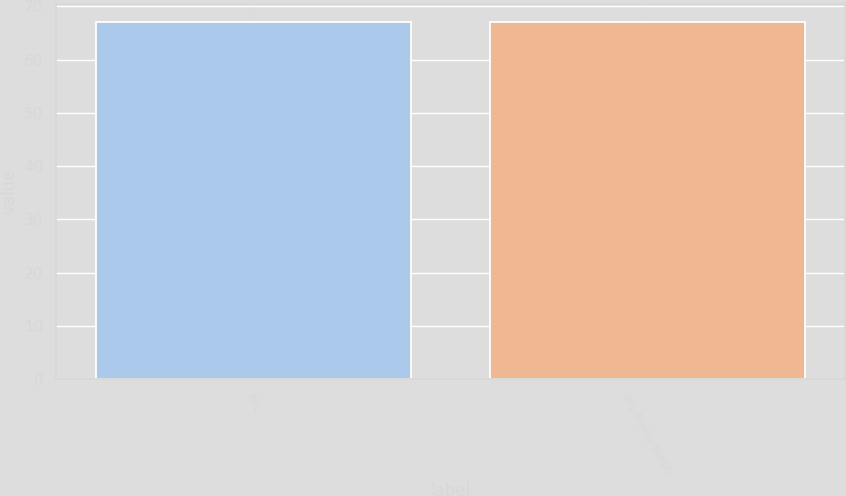Convert chart. <chart><loc_0><loc_0><loc_500><loc_500><bar_chart><fcel>PPL<fcel>PPL Energy Supply<nl><fcel>67<fcel>67.1<nl></chart> 